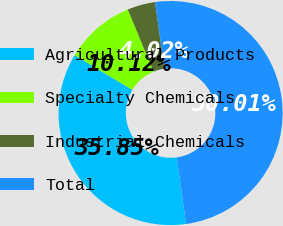Convert chart to OTSL. <chart><loc_0><loc_0><loc_500><loc_500><pie_chart><fcel>Agricultural Products<fcel>Specialty Chemicals<fcel>Industrial Chemicals<fcel>Total<nl><fcel>35.85%<fcel>10.12%<fcel>4.02%<fcel>50.0%<nl></chart> 